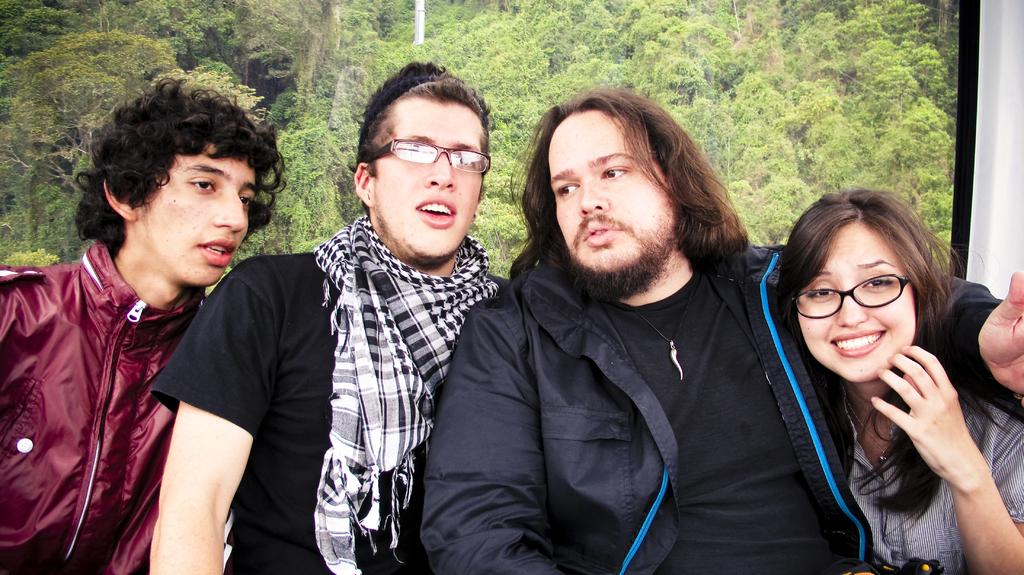How many people are present in the image? There are four persons in the image. What can be seen in the background of the image? There are trees in the background of the image. What type of engine can be seen powering the bike in the image? There is no bike or engine present in the image. What flavor of eggnog is being consumed by the persons in the image? There is no eggnog present in the image, and it is not mentioned that the persons are consuming any beverages. 